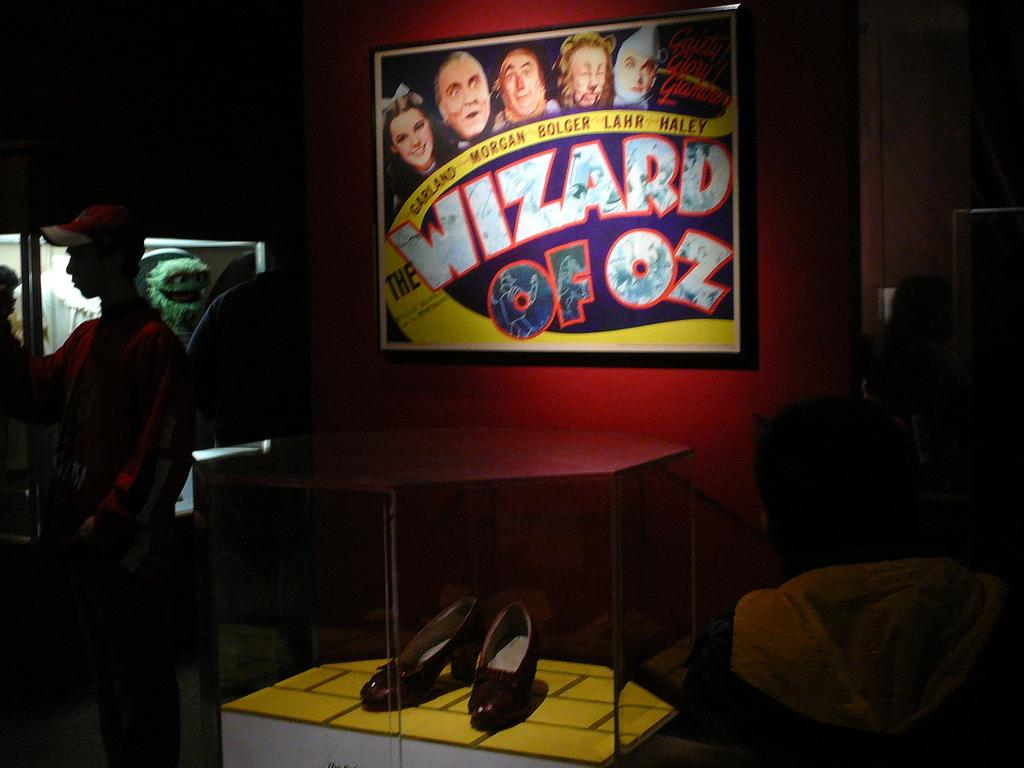What is placed inside the glass box in the image? There is a pair of shoe heels in a glass box in the image. What can be seen in the background of the image? There is a group of people standing in the background of the image. What type of object is present in the image that is typically associated with play? There is a toy in the image. What is attached to the wall in the image? There is a frame attached to the wall in the image. What type of needle can be seen being used by the people in the image? There is no needle present in the image; it features a pair of shoe heels in a glass box, a group of people standing, a toy, and a frame attached to the wall. 